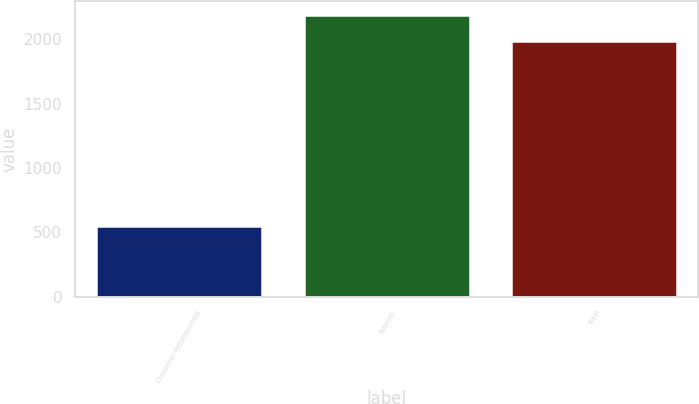Convert chart to OTSL. <chart><loc_0><loc_0><loc_500><loc_500><bar_chart><fcel>Customer Relationships<fcel>Patents<fcel>Total<nl><fcel>548<fcel>2188<fcel>1984<nl></chart> 